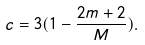<formula> <loc_0><loc_0><loc_500><loc_500>c = 3 ( 1 - \frac { 2 m + 2 } { M } ) .</formula> 